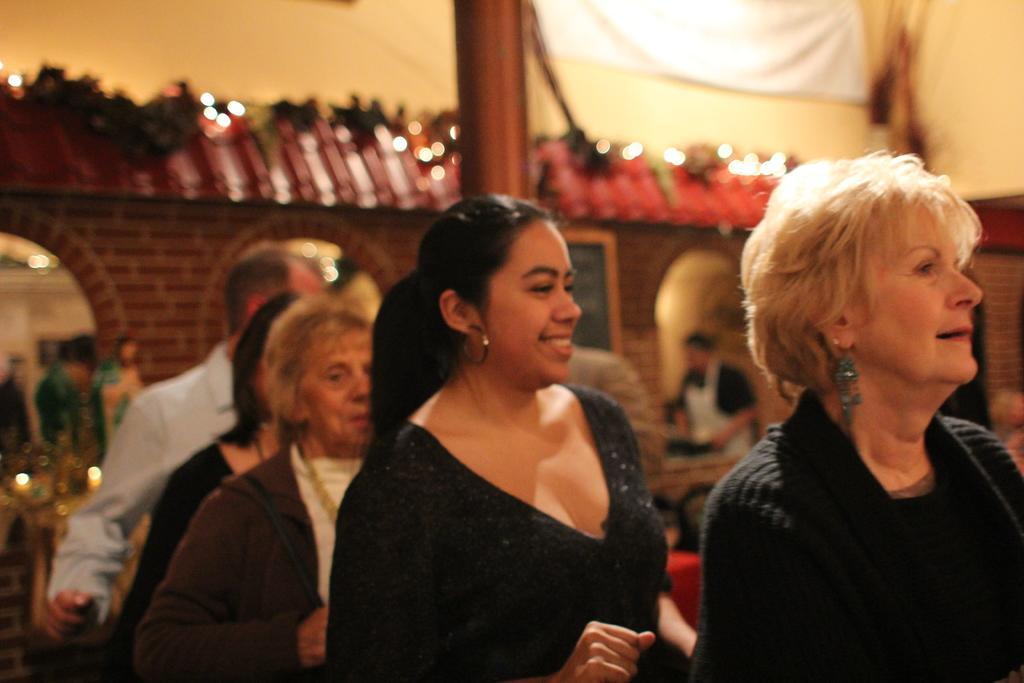In one or two sentences, can you explain what this image depicts? In the center of the image we can see a few people are standing and they are smiling, which we can see on their faces. And they are in different costumes. In the background there is a building, curtain, pole, board, lights, few people are standing and a few other objects. 